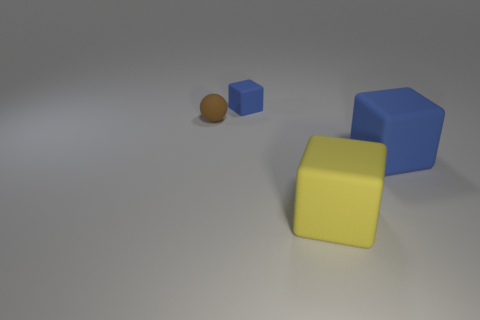Subtract all yellow balls. How many blue blocks are left? 2 Subtract all tiny blue matte blocks. How many blocks are left? 2 Add 3 brown rubber balls. How many objects exist? 7 Subtract all cyan blocks. Subtract all gray cylinders. How many blocks are left? 3 Subtract all balls. How many objects are left? 3 Subtract all green matte spheres. Subtract all blue objects. How many objects are left? 2 Add 1 tiny blue matte cubes. How many tiny blue matte cubes are left? 2 Add 3 small spheres. How many small spheres exist? 4 Subtract 2 blue blocks. How many objects are left? 2 